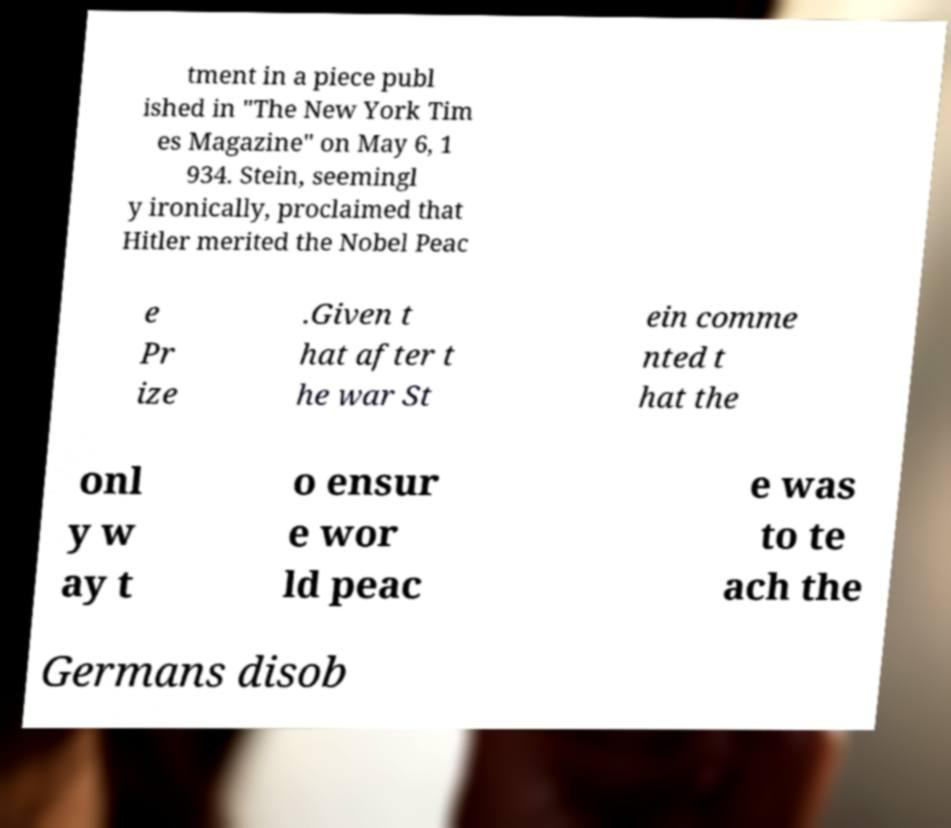Could you extract and type out the text from this image? tment in a piece publ ished in "The New York Tim es Magazine" on May 6, 1 934. Stein, seemingl y ironically, proclaimed that Hitler merited the Nobel Peac e Pr ize .Given t hat after t he war St ein comme nted t hat the onl y w ay t o ensur e wor ld peac e was to te ach the Germans disob 